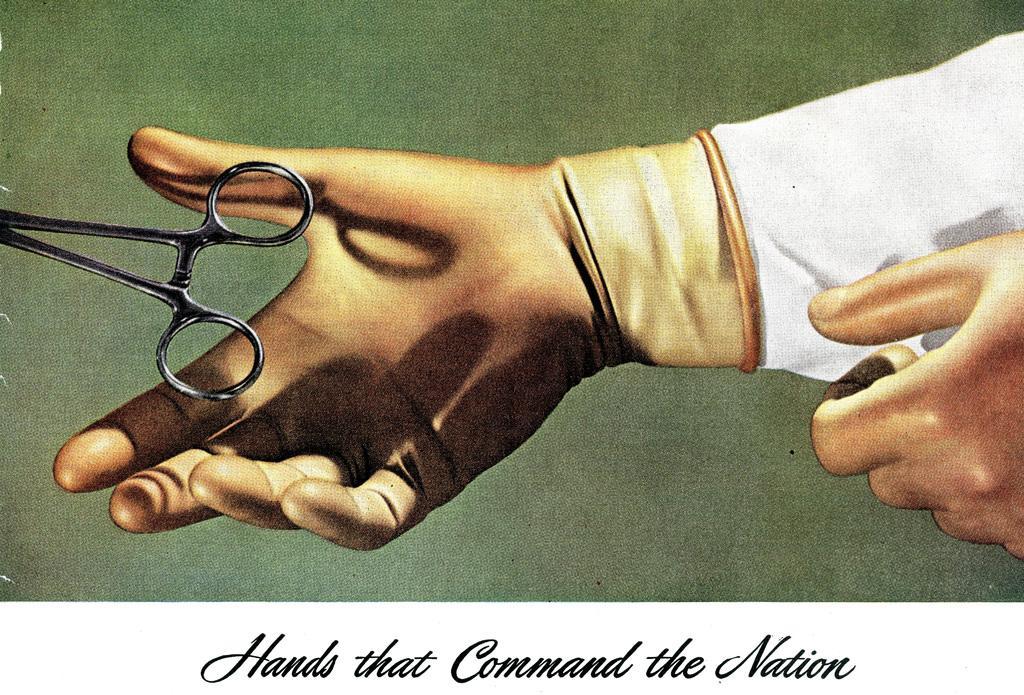How would you summarize this image in a sentence or two? In this image we can see painting of hand and scissor. At the bottom of the image we can see text. 